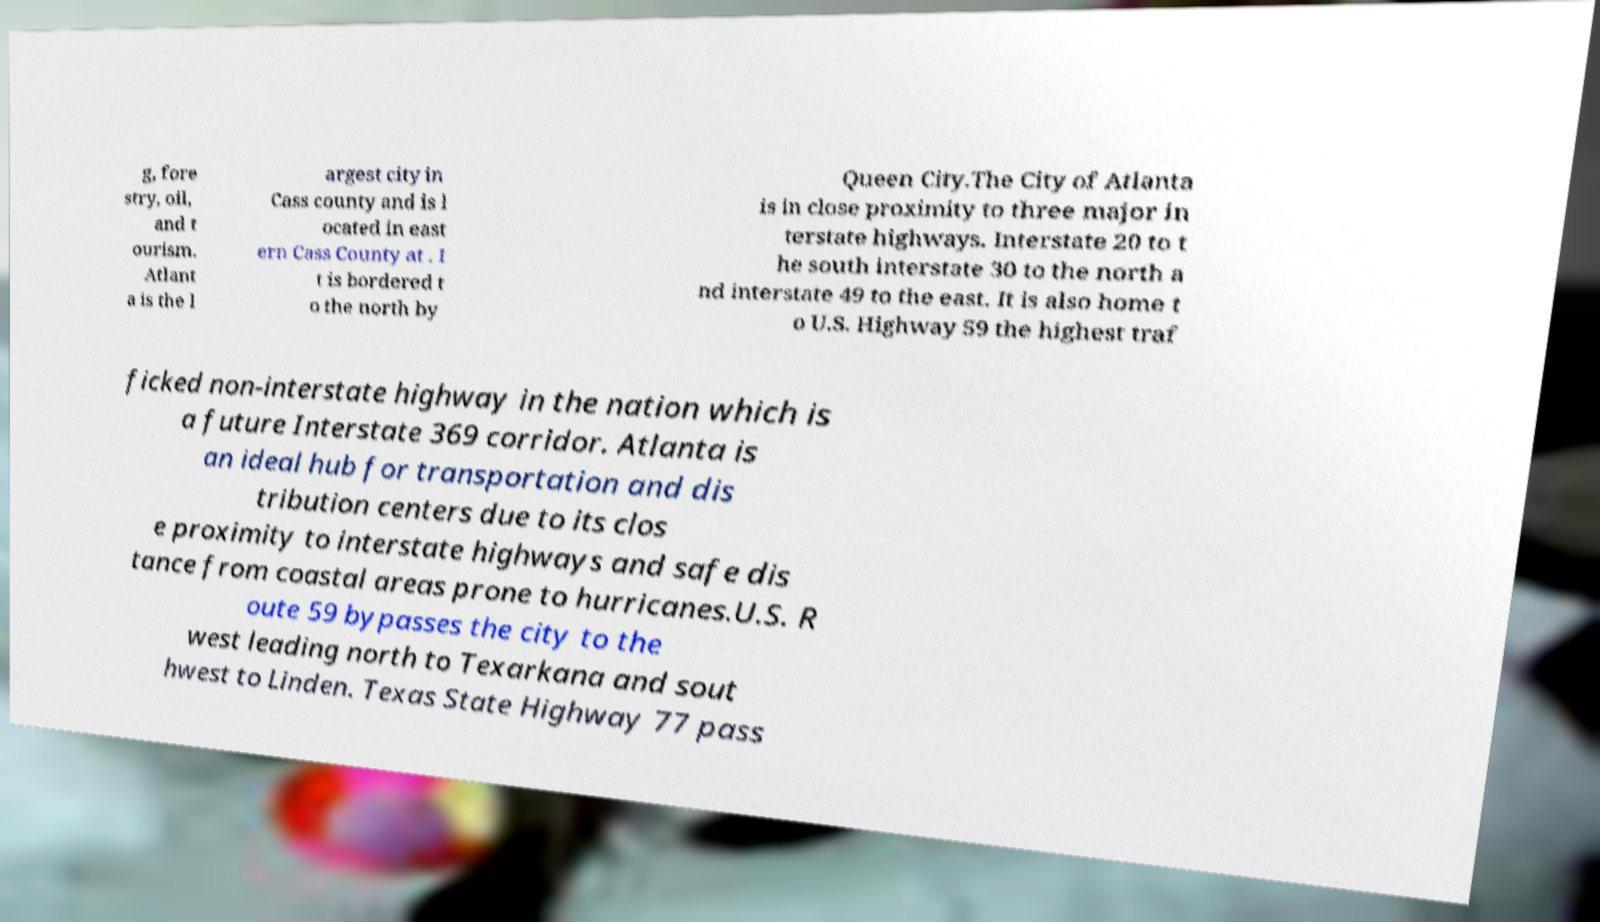For documentation purposes, I need the text within this image transcribed. Could you provide that? g, fore stry, oil, and t ourism. Atlant a is the l argest city in Cass county and is l ocated in east ern Cass County at . I t is bordered t o the north by Queen City.The City of Atlanta is in close proximity to three major in terstate highways. Interstate 20 to t he south interstate 30 to the north a nd interstate 49 to the east. It is also home t o U.S. Highway 59 the highest traf ficked non-interstate highway in the nation which is a future Interstate 369 corridor. Atlanta is an ideal hub for transportation and dis tribution centers due to its clos e proximity to interstate highways and safe dis tance from coastal areas prone to hurricanes.U.S. R oute 59 bypasses the city to the west leading north to Texarkana and sout hwest to Linden. Texas State Highway 77 pass 